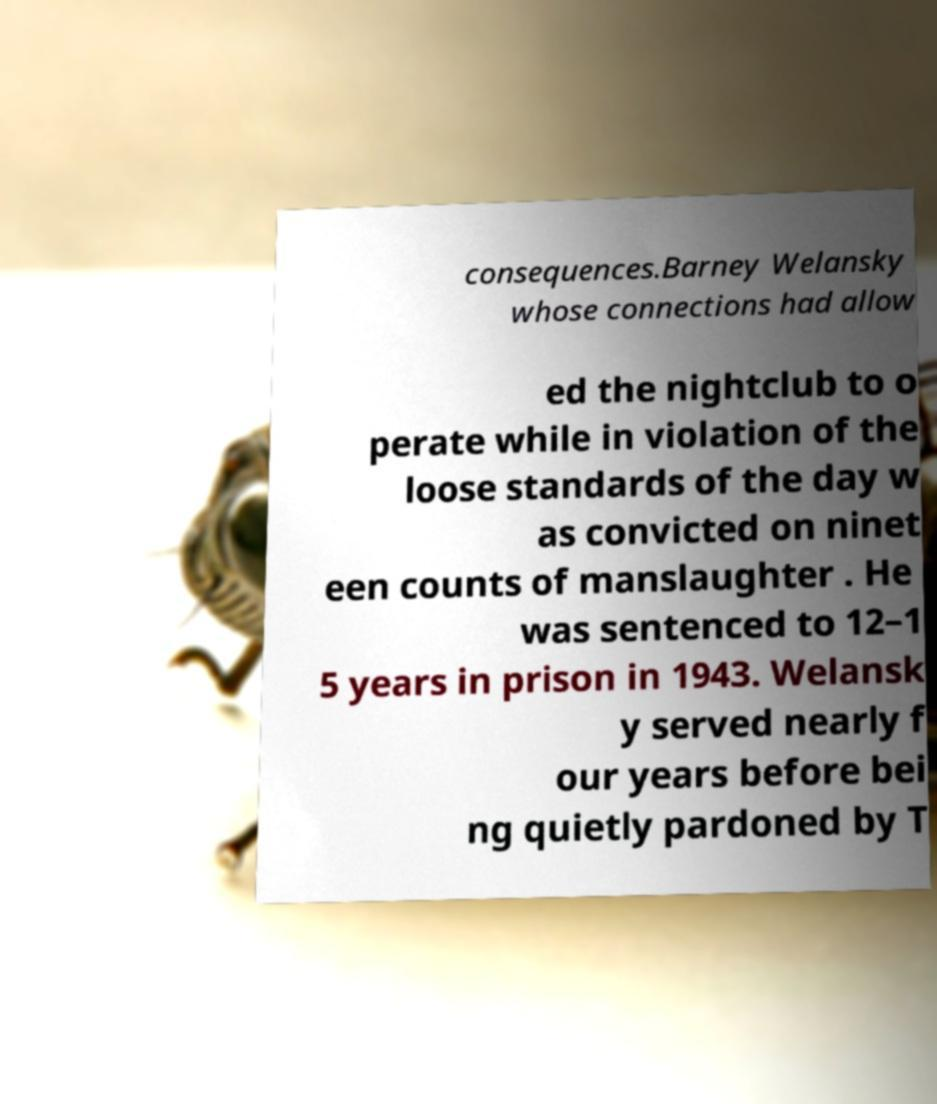There's text embedded in this image that I need extracted. Can you transcribe it verbatim? consequences.Barney Welansky whose connections had allow ed the nightclub to o perate while in violation of the loose standards of the day w as convicted on ninet een counts of manslaughter . He was sentenced to 12–1 5 years in prison in 1943. Welansk y served nearly f our years before bei ng quietly pardoned by T 